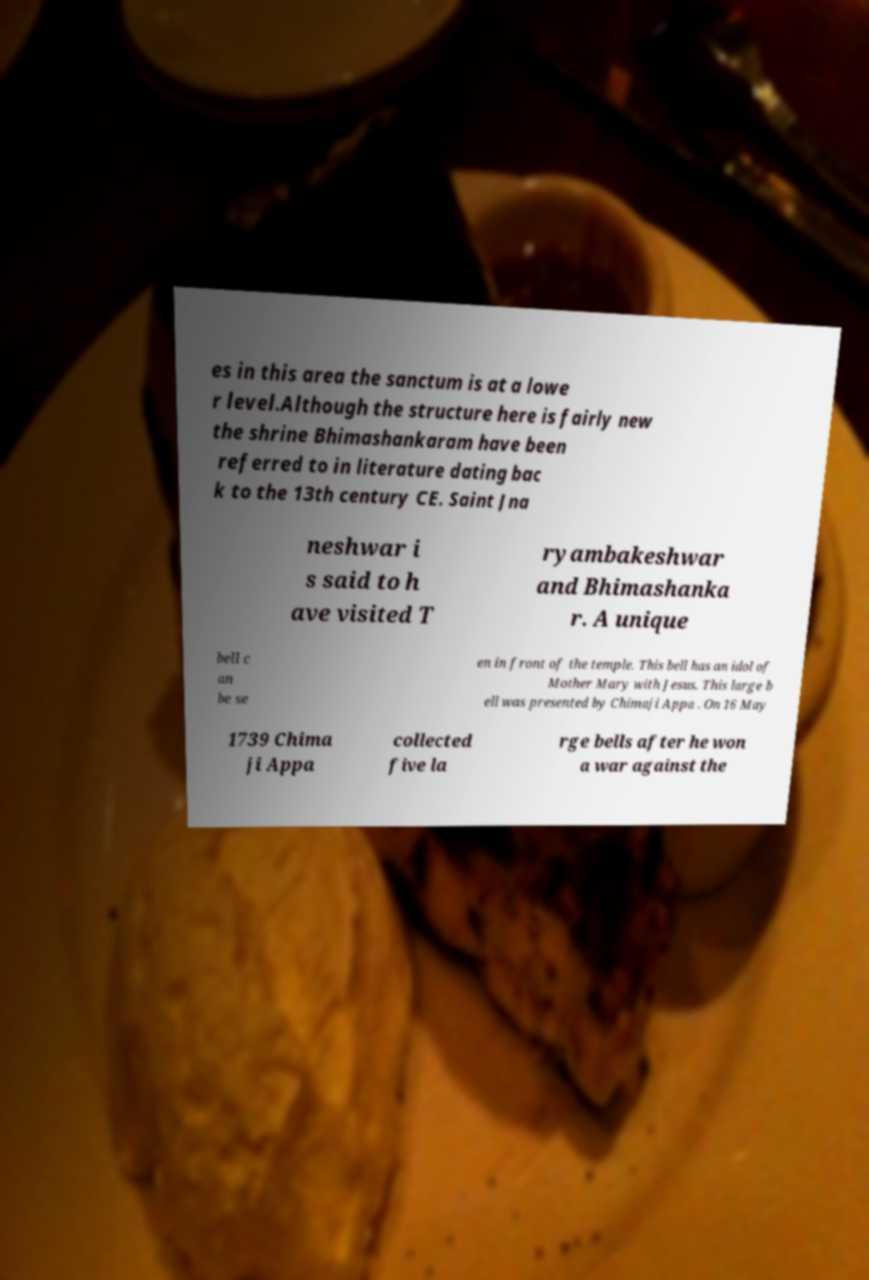Could you assist in decoding the text presented in this image and type it out clearly? es in this area the sanctum is at a lowe r level.Although the structure here is fairly new the shrine Bhimashankaram have been referred to in literature dating bac k to the 13th century CE. Saint Jna neshwar i s said to h ave visited T ryambakeshwar and Bhimashanka r. A unique bell c an be se en in front of the temple. This bell has an idol of Mother Mary with Jesus. This large b ell was presented by Chimaji Appa . On 16 May 1739 Chima ji Appa collected five la rge bells after he won a war against the 